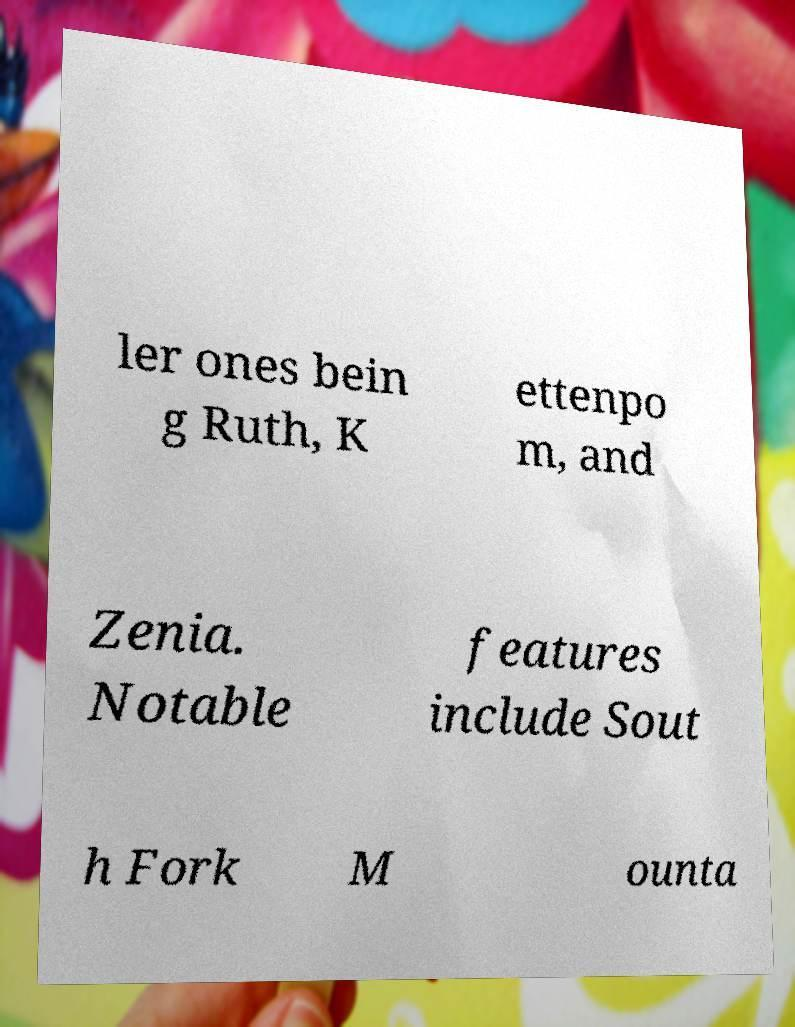There's text embedded in this image that I need extracted. Can you transcribe it verbatim? ler ones bein g Ruth, K ettenpo m, and Zenia. Notable features include Sout h Fork M ounta 